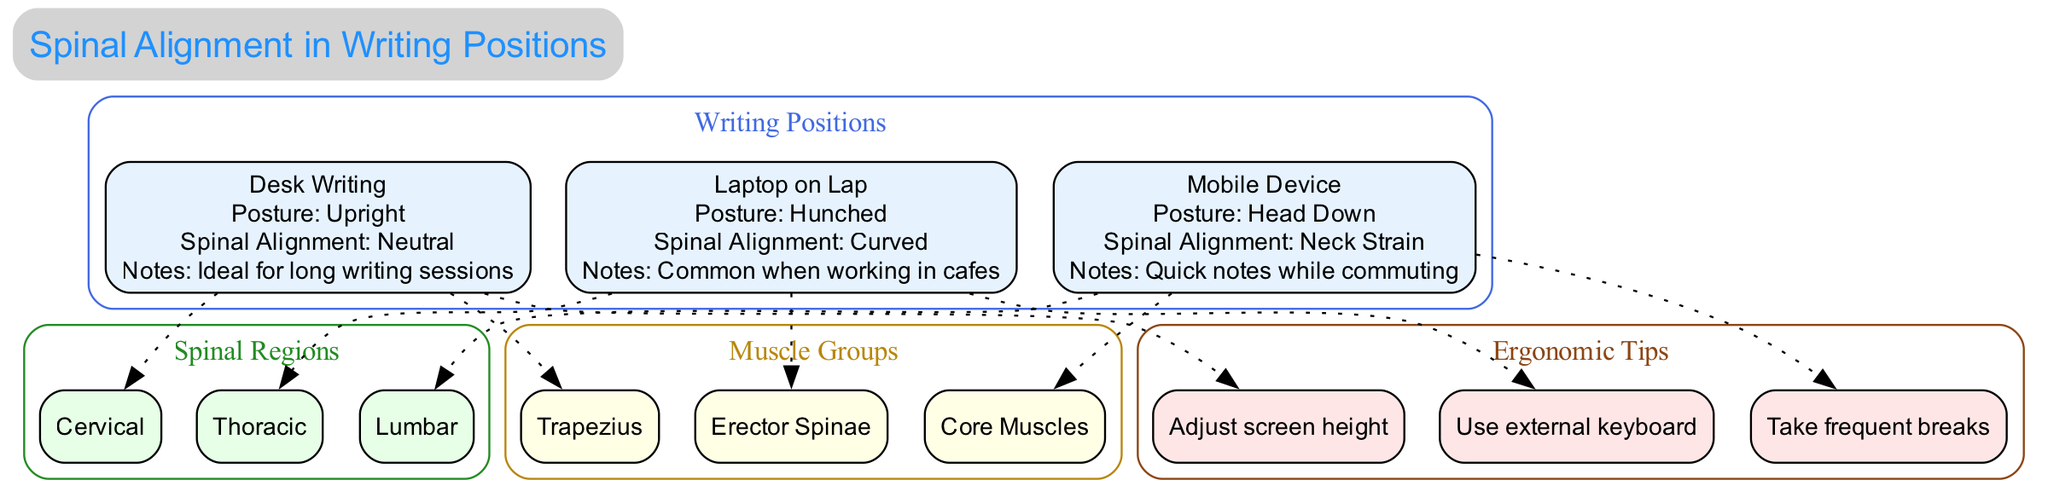What are the three writing positions shown in the diagram? The diagram lists three specific writing positions: "Desk Writing," "Laptop on Lap," and "Mobile Device." Each position is visually and textually represented, making it straightforward to identify them.
Answer: Desk Writing, Laptop on Lap, Mobile Device What is the posture for Desk Writing? The diagram specifies the posture associated with Desk Writing as "Upright," which is highlighted clearly within the relevant node of the diagram.
Answer: Upright How many spinal regions are addressed in the diagram? The diagram outlines three spinal regions: "Cervical," "Thoracic," and "Lumbar." Counting these nodes gives a total of three spinal regions.
Answer: 3 What is the spinal alignment for Mobile Device usage? According to the diagram, the spinal alignment associated with Mobile Device usage is labeled as "Neck Strain." This specific alignment is detailed within the Mobile Device node.
Answer: Neck Strain Which writing position is labeled with a "Curved" spinal alignment? The diagram indicates that the "Laptop on Lap" position is associated with a "Curved" spinal alignment, as stated directly within that position's information.
Answer: Laptop on Lap What ergonomic tips are suggested in the diagram? The diagram provides three ergonomic tips: "Adjust screen height," "Use external keyboard," and "Take frequent breaks." Collectively listing these tips is straightforward from the tips section in the diagram.
Answer: Adjust screen height, Use external keyboard, Take frequent breaks Which muscle group is linked to the Laptop on Lap position? The diagram links the "Trapezius," "Erector Spinae," and "Core Muscles" as muscle groups related to the various writing positions, and the Laptop on Lap position will correspond to one of these. After analyzing the nodes, it can be concluded that "Trapezius" is associated with that position.
Answer: Trapezius What is the posture for mobile device usage? The diagram specifies that the posture for mobile device usage is "Head Down," which is visually represented and noted within the corresponding node for Mobile Device usage.
Answer: Head Down 